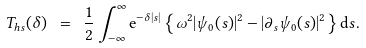Convert formula to latex. <formula><loc_0><loc_0><loc_500><loc_500>T _ { h s } ( \delta ) \ = \ \frac { 1 } { 2 } \int _ { - \infty } ^ { \infty } \mathrm e ^ { - \delta | s | } \left \{ \omega ^ { 2 } | \psi _ { 0 } ( s ) | ^ { 2 } - | \partial _ { s } \psi _ { 0 } ( s ) | ^ { 2 } \right \} \mathrm d s .</formula> 